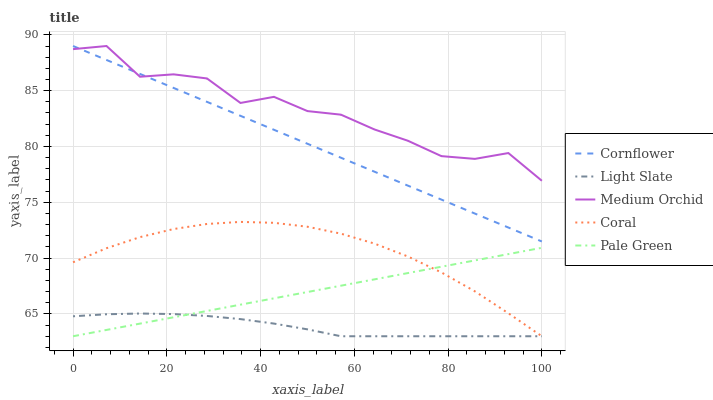Does Cornflower have the minimum area under the curve?
Answer yes or no. No. Does Cornflower have the maximum area under the curve?
Answer yes or no. No. Is Cornflower the smoothest?
Answer yes or no. No. Is Cornflower the roughest?
Answer yes or no. No. Does Cornflower have the lowest value?
Answer yes or no. No. Does Coral have the highest value?
Answer yes or no. No. Is Pale Green less than Medium Orchid?
Answer yes or no. Yes. Is Medium Orchid greater than Light Slate?
Answer yes or no. Yes. Does Pale Green intersect Medium Orchid?
Answer yes or no. No. 